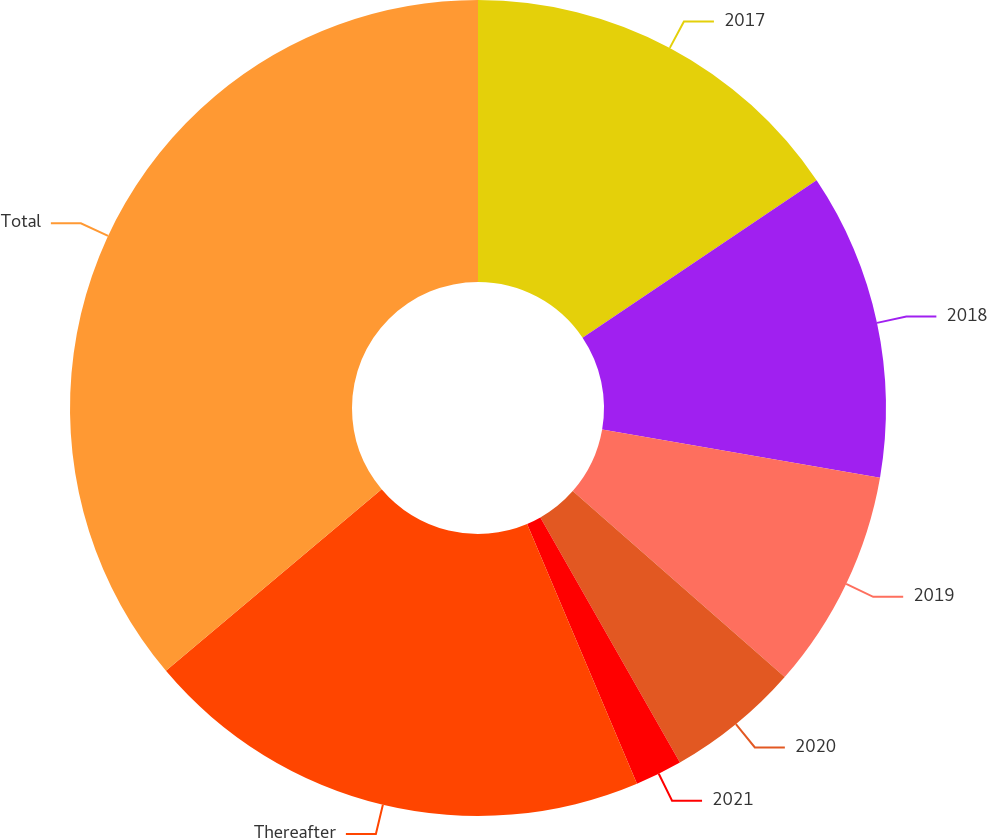Convert chart. <chart><loc_0><loc_0><loc_500><loc_500><pie_chart><fcel>2017<fcel>2018<fcel>2019<fcel>2020<fcel>2021<fcel>Thereafter<fcel>Total<nl><fcel>15.58%<fcel>12.15%<fcel>8.73%<fcel>5.3%<fcel>1.87%<fcel>20.23%<fcel>36.14%<nl></chart> 